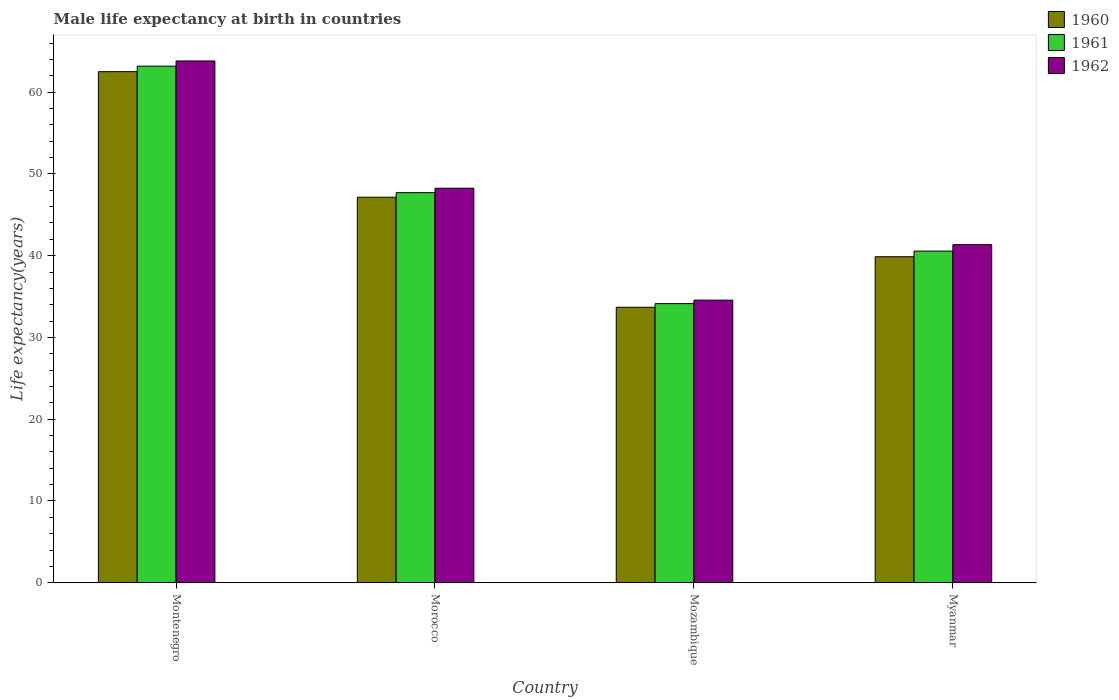How many different coloured bars are there?
Offer a very short reply. 3. What is the label of the 2nd group of bars from the left?
Ensure brevity in your answer.  Morocco. In how many cases, is the number of bars for a given country not equal to the number of legend labels?
Offer a terse response. 0. What is the male life expectancy at birth in 1960 in Morocco?
Provide a short and direct response. 47.15. Across all countries, what is the maximum male life expectancy at birth in 1961?
Make the answer very short. 63.18. Across all countries, what is the minimum male life expectancy at birth in 1961?
Your answer should be very brief. 34.14. In which country was the male life expectancy at birth in 1962 maximum?
Your response must be concise. Montenegro. In which country was the male life expectancy at birth in 1962 minimum?
Your answer should be very brief. Mozambique. What is the total male life expectancy at birth in 1961 in the graph?
Ensure brevity in your answer.  185.59. What is the difference between the male life expectancy at birth in 1962 in Montenegro and that in Mozambique?
Give a very brief answer. 29.26. What is the difference between the male life expectancy at birth in 1961 in Morocco and the male life expectancy at birth in 1960 in Montenegro?
Provide a succinct answer. -14.8. What is the average male life expectancy at birth in 1962 per country?
Provide a succinct answer. 46.99. What is the difference between the male life expectancy at birth of/in 1961 and male life expectancy at birth of/in 1962 in Mozambique?
Your response must be concise. -0.43. What is the ratio of the male life expectancy at birth in 1962 in Montenegro to that in Myanmar?
Your answer should be very brief. 1.54. Is the male life expectancy at birth in 1960 in Montenegro less than that in Myanmar?
Offer a terse response. No. Is the difference between the male life expectancy at birth in 1961 in Morocco and Myanmar greater than the difference between the male life expectancy at birth in 1962 in Morocco and Myanmar?
Your response must be concise. Yes. What is the difference between the highest and the second highest male life expectancy at birth in 1961?
Your response must be concise. -7.15. What is the difference between the highest and the lowest male life expectancy at birth in 1962?
Keep it short and to the point. 29.26. In how many countries, is the male life expectancy at birth in 1961 greater than the average male life expectancy at birth in 1961 taken over all countries?
Your response must be concise. 2. What does the 1st bar from the left in Mozambique represents?
Your answer should be compact. 1960. Is it the case that in every country, the sum of the male life expectancy at birth in 1961 and male life expectancy at birth in 1960 is greater than the male life expectancy at birth in 1962?
Your answer should be very brief. Yes. What is the difference between two consecutive major ticks on the Y-axis?
Provide a succinct answer. 10. Does the graph contain grids?
Your answer should be compact. No. Where does the legend appear in the graph?
Ensure brevity in your answer.  Top right. How many legend labels are there?
Your answer should be compact. 3. What is the title of the graph?
Ensure brevity in your answer.  Male life expectancy at birth in countries. What is the label or title of the Y-axis?
Provide a short and direct response. Life expectancy(years). What is the Life expectancy(years) in 1960 in Montenegro?
Ensure brevity in your answer.  62.51. What is the Life expectancy(years) in 1961 in Montenegro?
Make the answer very short. 63.18. What is the Life expectancy(years) in 1962 in Montenegro?
Offer a very short reply. 63.82. What is the Life expectancy(years) in 1960 in Morocco?
Offer a very short reply. 47.15. What is the Life expectancy(years) of 1961 in Morocco?
Your answer should be compact. 47.71. What is the Life expectancy(years) in 1962 in Morocco?
Give a very brief answer. 48.25. What is the Life expectancy(years) of 1960 in Mozambique?
Keep it short and to the point. 33.69. What is the Life expectancy(years) in 1961 in Mozambique?
Ensure brevity in your answer.  34.14. What is the Life expectancy(years) in 1962 in Mozambique?
Your answer should be very brief. 34.56. What is the Life expectancy(years) in 1960 in Myanmar?
Make the answer very short. 39.87. What is the Life expectancy(years) in 1961 in Myanmar?
Your answer should be compact. 40.56. What is the Life expectancy(years) in 1962 in Myanmar?
Your answer should be very brief. 41.35. Across all countries, what is the maximum Life expectancy(years) of 1960?
Your answer should be compact. 62.51. Across all countries, what is the maximum Life expectancy(years) of 1961?
Offer a terse response. 63.18. Across all countries, what is the maximum Life expectancy(years) of 1962?
Provide a short and direct response. 63.82. Across all countries, what is the minimum Life expectancy(years) in 1960?
Make the answer very short. 33.69. Across all countries, what is the minimum Life expectancy(years) of 1961?
Your answer should be compact. 34.14. Across all countries, what is the minimum Life expectancy(years) in 1962?
Your answer should be very brief. 34.56. What is the total Life expectancy(years) of 1960 in the graph?
Your answer should be compact. 183.23. What is the total Life expectancy(years) of 1961 in the graph?
Provide a succinct answer. 185.59. What is the total Life expectancy(years) of 1962 in the graph?
Your response must be concise. 187.98. What is the difference between the Life expectancy(years) of 1960 in Montenegro and that in Morocco?
Provide a succinct answer. 15.36. What is the difference between the Life expectancy(years) of 1961 in Montenegro and that in Morocco?
Offer a very short reply. 15.47. What is the difference between the Life expectancy(years) in 1962 in Montenegro and that in Morocco?
Your answer should be compact. 15.57. What is the difference between the Life expectancy(years) of 1960 in Montenegro and that in Mozambique?
Make the answer very short. 28.82. What is the difference between the Life expectancy(years) in 1961 in Montenegro and that in Mozambique?
Provide a short and direct response. 29.05. What is the difference between the Life expectancy(years) of 1962 in Montenegro and that in Mozambique?
Offer a terse response. 29.25. What is the difference between the Life expectancy(years) of 1960 in Montenegro and that in Myanmar?
Keep it short and to the point. 22.64. What is the difference between the Life expectancy(years) of 1961 in Montenegro and that in Myanmar?
Provide a short and direct response. 22.62. What is the difference between the Life expectancy(years) in 1962 in Montenegro and that in Myanmar?
Give a very brief answer. 22.47. What is the difference between the Life expectancy(years) of 1960 in Morocco and that in Mozambique?
Make the answer very short. 13.46. What is the difference between the Life expectancy(years) of 1961 in Morocco and that in Mozambique?
Ensure brevity in your answer.  13.57. What is the difference between the Life expectancy(years) of 1962 in Morocco and that in Mozambique?
Give a very brief answer. 13.69. What is the difference between the Life expectancy(years) of 1960 in Morocco and that in Myanmar?
Make the answer very short. 7.28. What is the difference between the Life expectancy(years) in 1961 in Morocco and that in Myanmar?
Ensure brevity in your answer.  7.14. What is the difference between the Life expectancy(years) of 1962 in Morocco and that in Myanmar?
Give a very brief answer. 6.91. What is the difference between the Life expectancy(years) of 1960 in Mozambique and that in Myanmar?
Keep it short and to the point. -6.18. What is the difference between the Life expectancy(years) in 1961 in Mozambique and that in Myanmar?
Ensure brevity in your answer.  -6.43. What is the difference between the Life expectancy(years) of 1962 in Mozambique and that in Myanmar?
Your answer should be very brief. -6.78. What is the difference between the Life expectancy(years) of 1960 in Montenegro and the Life expectancy(years) of 1961 in Morocco?
Make the answer very short. 14.8. What is the difference between the Life expectancy(years) of 1960 in Montenegro and the Life expectancy(years) of 1962 in Morocco?
Ensure brevity in your answer.  14.26. What is the difference between the Life expectancy(years) of 1961 in Montenegro and the Life expectancy(years) of 1962 in Morocco?
Keep it short and to the point. 14.93. What is the difference between the Life expectancy(years) in 1960 in Montenegro and the Life expectancy(years) in 1961 in Mozambique?
Provide a succinct answer. 28.37. What is the difference between the Life expectancy(years) of 1960 in Montenegro and the Life expectancy(years) of 1962 in Mozambique?
Your answer should be compact. 27.95. What is the difference between the Life expectancy(years) in 1961 in Montenegro and the Life expectancy(years) in 1962 in Mozambique?
Provide a short and direct response. 28.62. What is the difference between the Life expectancy(years) in 1960 in Montenegro and the Life expectancy(years) in 1961 in Myanmar?
Ensure brevity in your answer.  21.95. What is the difference between the Life expectancy(years) of 1960 in Montenegro and the Life expectancy(years) of 1962 in Myanmar?
Ensure brevity in your answer.  21.16. What is the difference between the Life expectancy(years) in 1961 in Montenegro and the Life expectancy(years) in 1962 in Myanmar?
Offer a terse response. 21.84. What is the difference between the Life expectancy(years) in 1960 in Morocco and the Life expectancy(years) in 1961 in Mozambique?
Provide a short and direct response. 13.02. What is the difference between the Life expectancy(years) of 1960 in Morocco and the Life expectancy(years) of 1962 in Mozambique?
Give a very brief answer. 12.59. What is the difference between the Life expectancy(years) in 1961 in Morocco and the Life expectancy(years) in 1962 in Mozambique?
Offer a very short reply. 13.15. What is the difference between the Life expectancy(years) of 1960 in Morocco and the Life expectancy(years) of 1961 in Myanmar?
Provide a short and direct response. 6.59. What is the difference between the Life expectancy(years) in 1960 in Morocco and the Life expectancy(years) in 1962 in Myanmar?
Offer a very short reply. 5.81. What is the difference between the Life expectancy(years) of 1961 in Morocco and the Life expectancy(years) of 1962 in Myanmar?
Offer a terse response. 6.36. What is the difference between the Life expectancy(years) in 1960 in Mozambique and the Life expectancy(years) in 1961 in Myanmar?
Keep it short and to the point. -6.87. What is the difference between the Life expectancy(years) in 1960 in Mozambique and the Life expectancy(years) in 1962 in Myanmar?
Offer a terse response. -7.65. What is the difference between the Life expectancy(years) of 1961 in Mozambique and the Life expectancy(years) of 1962 in Myanmar?
Keep it short and to the point. -7.21. What is the average Life expectancy(years) of 1960 per country?
Your answer should be very brief. 45.81. What is the average Life expectancy(years) of 1961 per country?
Keep it short and to the point. 46.4. What is the average Life expectancy(years) in 1962 per country?
Your answer should be very brief. 46.99. What is the difference between the Life expectancy(years) of 1960 and Life expectancy(years) of 1961 in Montenegro?
Offer a terse response. -0.67. What is the difference between the Life expectancy(years) of 1960 and Life expectancy(years) of 1962 in Montenegro?
Make the answer very short. -1.31. What is the difference between the Life expectancy(years) of 1961 and Life expectancy(years) of 1962 in Montenegro?
Your answer should be compact. -0.64. What is the difference between the Life expectancy(years) of 1960 and Life expectancy(years) of 1961 in Morocco?
Your answer should be compact. -0.56. What is the difference between the Life expectancy(years) of 1960 and Life expectancy(years) of 1962 in Morocco?
Your answer should be very brief. -1.1. What is the difference between the Life expectancy(years) in 1961 and Life expectancy(years) in 1962 in Morocco?
Ensure brevity in your answer.  -0.54. What is the difference between the Life expectancy(years) of 1960 and Life expectancy(years) of 1961 in Mozambique?
Offer a terse response. -0.45. What is the difference between the Life expectancy(years) of 1960 and Life expectancy(years) of 1962 in Mozambique?
Provide a short and direct response. -0.87. What is the difference between the Life expectancy(years) of 1961 and Life expectancy(years) of 1962 in Mozambique?
Make the answer very short. -0.43. What is the difference between the Life expectancy(years) of 1960 and Life expectancy(years) of 1961 in Myanmar?
Your answer should be very brief. -0.69. What is the difference between the Life expectancy(years) of 1960 and Life expectancy(years) of 1962 in Myanmar?
Make the answer very short. -1.47. What is the difference between the Life expectancy(years) of 1961 and Life expectancy(years) of 1962 in Myanmar?
Your answer should be very brief. -0.78. What is the ratio of the Life expectancy(years) in 1960 in Montenegro to that in Morocco?
Offer a terse response. 1.33. What is the ratio of the Life expectancy(years) in 1961 in Montenegro to that in Morocco?
Ensure brevity in your answer.  1.32. What is the ratio of the Life expectancy(years) in 1962 in Montenegro to that in Morocco?
Give a very brief answer. 1.32. What is the ratio of the Life expectancy(years) of 1960 in Montenegro to that in Mozambique?
Offer a very short reply. 1.86. What is the ratio of the Life expectancy(years) of 1961 in Montenegro to that in Mozambique?
Ensure brevity in your answer.  1.85. What is the ratio of the Life expectancy(years) of 1962 in Montenegro to that in Mozambique?
Your response must be concise. 1.85. What is the ratio of the Life expectancy(years) of 1960 in Montenegro to that in Myanmar?
Your response must be concise. 1.57. What is the ratio of the Life expectancy(years) in 1961 in Montenegro to that in Myanmar?
Ensure brevity in your answer.  1.56. What is the ratio of the Life expectancy(years) in 1962 in Montenegro to that in Myanmar?
Your answer should be very brief. 1.54. What is the ratio of the Life expectancy(years) of 1960 in Morocco to that in Mozambique?
Your answer should be very brief. 1.4. What is the ratio of the Life expectancy(years) in 1961 in Morocco to that in Mozambique?
Offer a terse response. 1.4. What is the ratio of the Life expectancy(years) in 1962 in Morocco to that in Mozambique?
Give a very brief answer. 1.4. What is the ratio of the Life expectancy(years) of 1960 in Morocco to that in Myanmar?
Your answer should be compact. 1.18. What is the ratio of the Life expectancy(years) of 1961 in Morocco to that in Myanmar?
Give a very brief answer. 1.18. What is the ratio of the Life expectancy(years) in 1962 in Morocco to that in Myanmar?
Your answer should be very brief. 1.17. What is the ratio of the Life expectancy(years) in 1960 in Mozambique to that in Myanmar?
Keep it short and to the point. 0.84. What is the ratio of the Life expectancy(years) in 1961 in Mozambique to that in Myanmar?
Your answer should be compact. 0.84. What is the ratio of the Life expectancy(years) in 1962 in Mozambique to that in Myanmar?
Give a very brief answer. 0.84. What is the difference between the highest and the second highest Life expectancy(years) in 1960?
Provide a succinct answer. 15.36. What is the difference between the highest and the second highest Life expectancy(years) of 1961?
Ensure brevity in your answer.  15.47. What is the difference between the highest and the second highest Life expectancy(years) of 1962?
Keep it short and to the point. 15.57. What is the difference between the highest and the lowest Life expectancy(years) of 1960?
Make the answer very short. 28.82. What is the difference between the highest and the lowest Life expectancy(years) in 1961?
Offer a very short reply. 29.05. What is the difference between the highest and the lowest Life expectancy(years) in 1962?
Your answer should be compact. 29.25. 